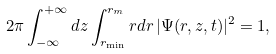Convert formula to latex. <formula><loc_0><loc_0><loc_500><loc_500>2 \pi \int _ { - \infty } ^ { + \infty } d z \int _ { r _ { \min } } ^ { r _ { m } } r d r \, | \Psi ( r , z , t ) | ^ { 2 } = 1 ,</formula> 